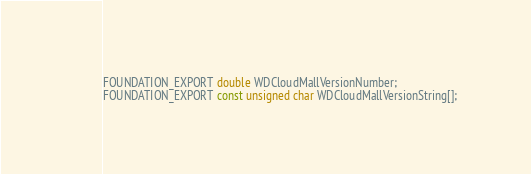Convert code to text. <code><loc_0><loc_0><loc_500><loc_500><_C_>FOUNDATION_EXPORT double WDCloudMallVersionNumber;
FOUNDATION_EXPORT const unsigned char WDCloudMallVersionString[];

</code> 